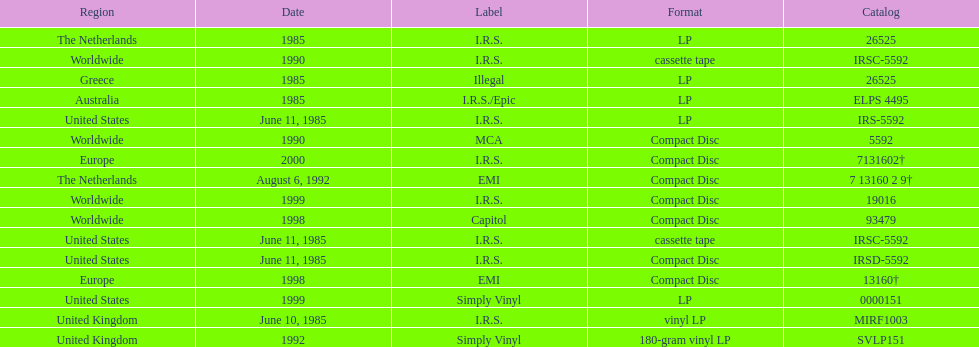What was the date of the first vinyl lp release? June 10, 1985. 